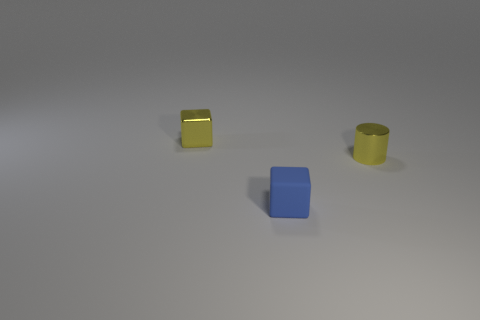Are there any other things that are the same material as the small blue block?
Provide a succinct answer. No. What is the material of the tiny yellow block?
Provide a succinct answer. Metal. The tiny yellow thing that is made of the same material as the tiny yellow cylinder is what shape?
Keep it short and to the point. Cube. What number of other objects are there of the same shape as the tiny matte thing?
Your answer should be compact. 1. There is a matte block; what number of tiny yellow shiny blocks are behind it?
Provide a succinct answer. 1. What is the block in front of the tiny yellow object that is to the left of the tiny blue cube to the left of the metal cylinder made of?
Your answer should be compact. Rubber. What is the size of the thing that is behind the rubber object and right of the shiny block?
Offer a very short reply. Small. Are there any tiny cubes that have the same color as the cylinder?
Provide a short and direct response. Yes. There is a tiny shiny object that is to the right of the cube in front of the metal cylinder; what color is it?
Provide a short and direct response. Yellow. Is the number of blue matte things that are behind the small yellow cube less than the number of tiny blocks behind the tiny yellow shiny cylinder?
Give a very brief answer. Yes. 